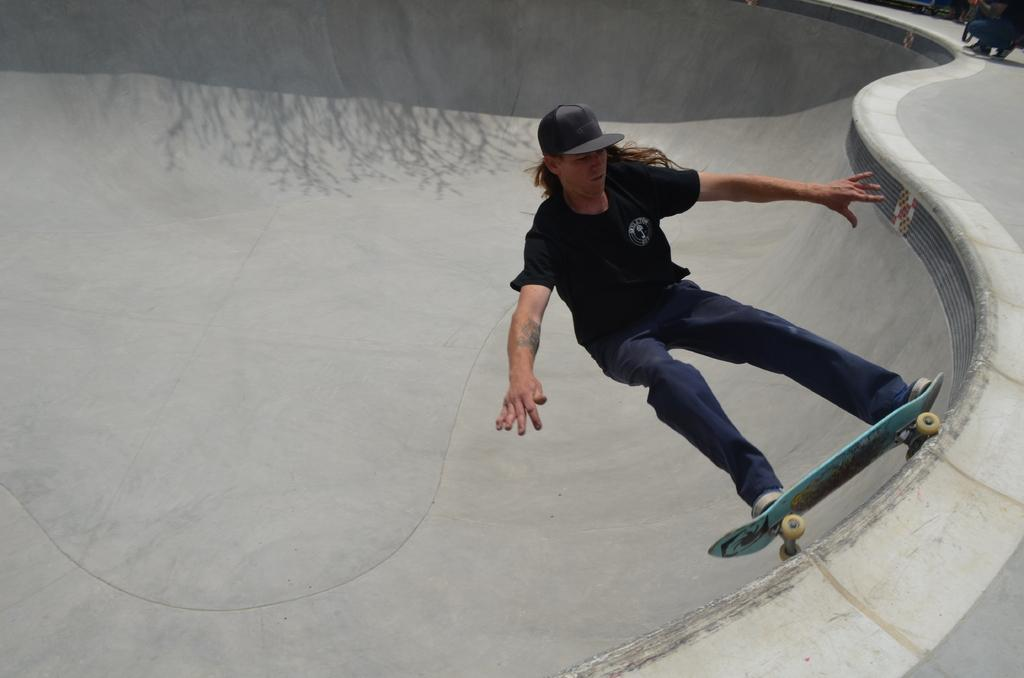What is the man in the image doing? The man is skating on a board in the image. What is the surface the man is skating on? The board is on a slope platform. What is the man wearing on his upper body? The man is wearing a black t-shirt. What is the man wearing on his lower body? The man is wearing blue jeans. Can you describe the person visible at the top right of the image? Unfortunately, the provided facts do not mention any details about the person at the top right of the image. What type of beam is holding up the sidewalk in the image? There is no sidewalk or beam present in the image; it features a man skating on a board on a slope platform. 